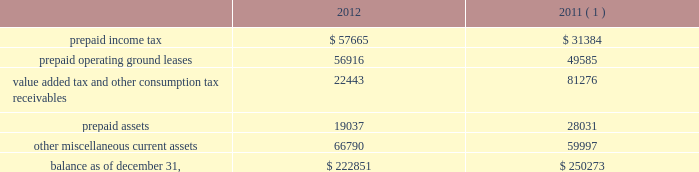American tower corporation and subsidiaries notes to consolidated financial statements loss on retirement of long-term obligations 2014loss on retirement of long-term obligations primarily includes cash paid to retire debt in excess of its carrying value , cash paid to holders of convertible notes in connection with note conversions and non-cash charges related to the write-off of deferred financing fees .
Loss on retirement of long-term obligations also includes gains from repurchasing or refinancing certain of the company 2019s debt obligations .
Earnings per common share 2014basic and diluted 2014basic income from continuing operations per common share for the years ended december 31 , 2012 , 2011 and 2010 represents income from continuing operations attributable to american tower corporation divided by the weighted average number of common shares outstanding during the period .
Diluted income from continuing operations per common share for the years ended december 31 , 2012 , 2011 and 2010 represents income from continuing operations attributable to american tower corporation divided by the weighted average number of common shares outstanding during the period and any dilutive common share equivalents , including unvested restricted stock , shares issuable upon exercise of stock options and warrants as determined under the treasury stock method and upon conversion of the company 2019s convertible notes , as determined under the if-converted method .
Retirement plan 2014the company has a 401 ( k ) plan covering substantially all employees who meet certain age and employment requirements .
The company 2019s matching contribution for the years ended december 31 , 2012 , 2011 and 2010 is 50% ( 50 % ) up to a maximum 6% ( 6 % ) of a participant 2019s contributions .
For the years ended december 31 , 2012 , 2011 and 2010 , the company contributed approximately $ 4.4 million , $ 2.9 million and $ 1.9 million to the plan , respectively .
Prepaid and other current assets prepaid and other current assets consist of the following as of december 31 , ( in thousands ) : .
( 1 ) december 31 , 2011 balances have been revised to reflect purchase accounting measurement period adjustments. .
For 2011 , tax related assets were how much of total current assets and prepaids? 
Computations: ((31384 + 81276) / 250273)
Answer: 0.45015. 